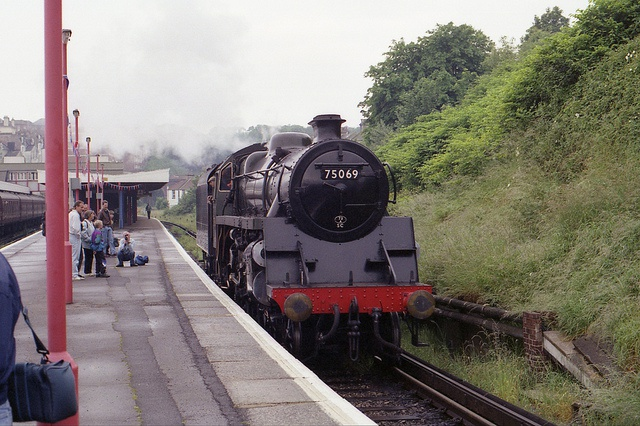Describe the objects in this image and their specific colors. I can see train in white, black, gray, and maroon tones, people in white, navy, black, gray, and purple tones, train in white, gray, and black tones, people in white, darkgray, lightgray, and gray tones, and people in white, black, gray, and darkgray tones in this image. 